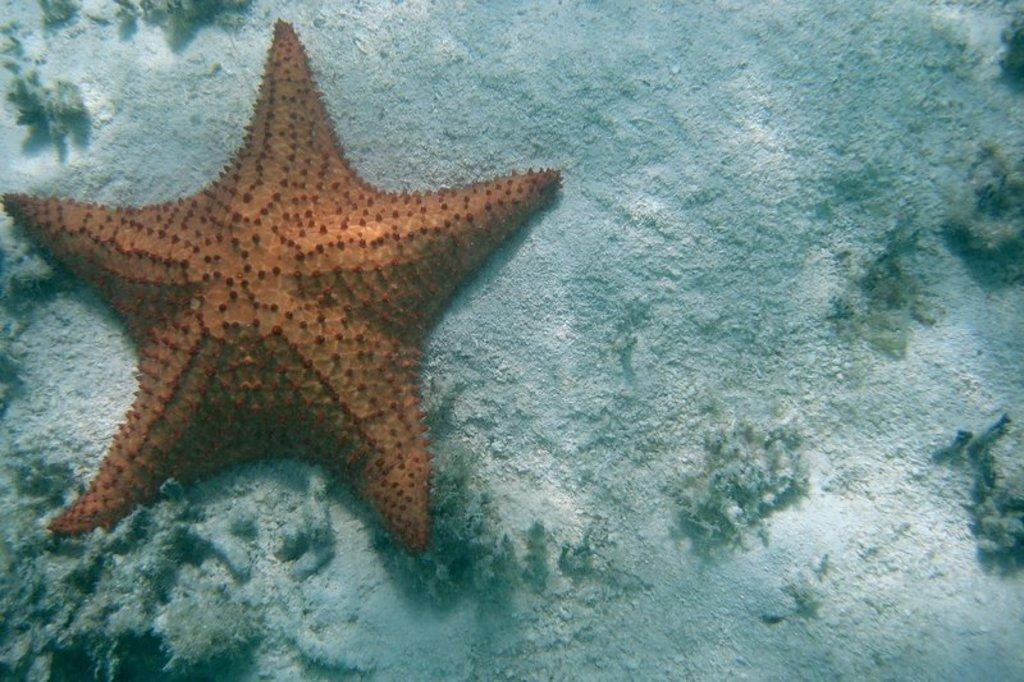What type of marine animals can be seen in the image? There are starfish visible under the water in the image. What type of surface can be seen in the background of the image? There is a ground visible in the background of the image. What type of plastic object can be seen in the image? There is no plastic object present in the image. Is there a rifle visible in the image? There is no rifle present in the image. Can you see any seeds in the image? There is no mention of seeds in the image. 